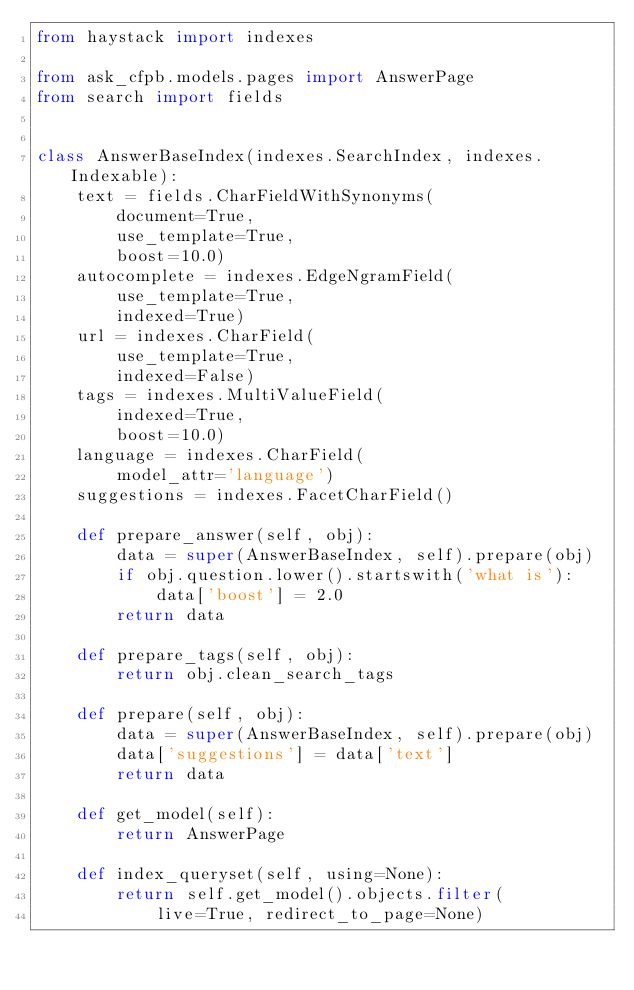Convert code to text. <code><loc_0><loc_0><loc_500><loc_500><_Python_>from haystack import indexes

from ask_cfpb.models.pages import AnswerPage
from search import fields


class AnswerBaseIndex(indexes.SearchIndex, indexes.Indexable):
    text = fields.CharFieldWithSynonyms(
        document=True,
        use_template=True,
        boost=10.0)
    autocomplete = indexes.EdgeNgramField(
        use_template=True,
        indexed=True)
    url = indexes.CharField(
        use_template=True,
        indexed=False)
    tags = indexes.MultiValueField(
        indexed=True,
        boost=10.0)
    language = indexes.CharField(
        model_attr='language')
    suggestions = indexes.FacetCharField()

    def prepare_answer(self, obj):
        data = super(AnswerBaseIndex, self).prepare(obj)
        if obj.question.lower().startswith('what is'):
            data['boost'] = 2.0
        return data

    def prepare_tags(self, obj):
        return obj.clean_search_tags

    def prepare(self, obj):
        data = super(AnswerBaseIndex, self).prepare(obj)
        data['suggestions'] = data['text']
        return data

    def get_model(self):
        return AnswerPage

    def index_queryset(self, using=None):
        return self.get_model().objects.filter(
            live=True, redirect_to_page=None)
</code> 